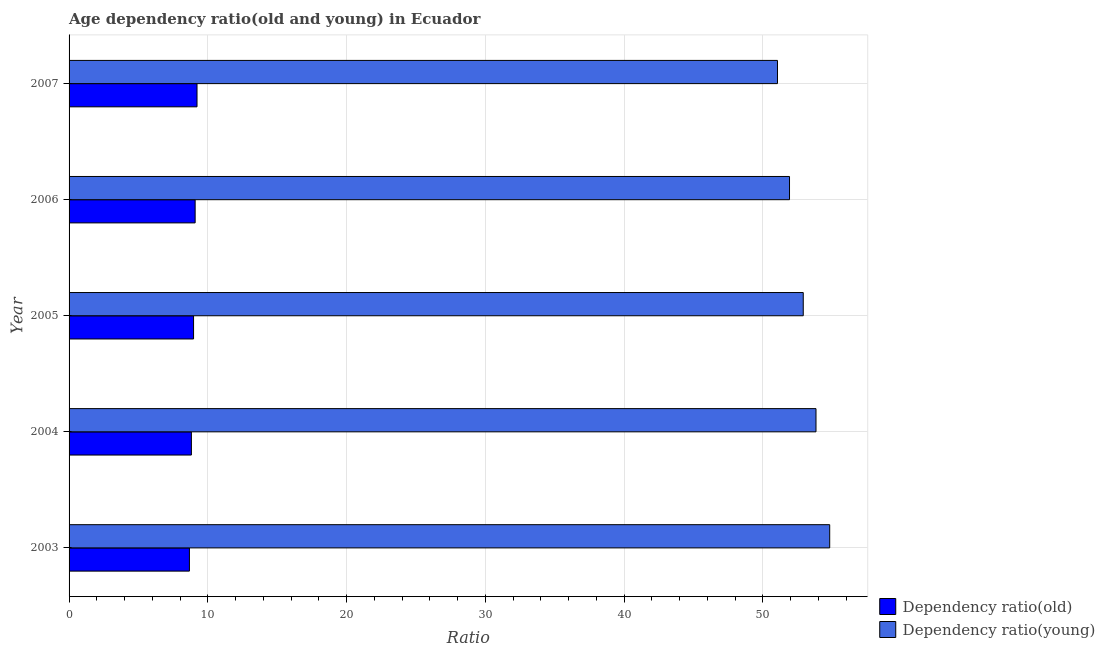How many different coloured bars are there?
Offer a very short reply. 2. How many groups of bars are there?
Keep it short and to the point. 5. In how many cases, is the number of bars for a given year not equal to the number of legend labels?
Ensure brevity in your answer.  0. What is the age dependency ratio(young) in 2005?
Your answer should be very brief. 52.92. Across all years, what is the maximum age dependency ratio(old)?
Your answer should be compact. 9.22. Across all years, what is the minimum age dependency ratio(old)?
Offer a very short reply. 8.67. In which year was the age dependency ratio(old) maximum?
Your answer should be compact. 2007. In which year was the age dependency ratio(young) minimum?
Keep it short and to the point. 2007. What is the total age dependency ratio(young) in the graph?
Ensure brevity in your answer.  264.57. What is the difference between the age dependency ratio(old) in 2003 and that in 2007?
Offer a very short reply. -0.55. What is the difference between the age dependency ratio(young) in 2004 and the age dependency ratio(old) in 2005?
Your response must be concise. 44.86. What is the average age dependency ratio(young) per year?
Give a very brief answer. 52.91. In the year 2006, what is the difference between the age dependency ratio(old) and age dependency ratio(young)?
Your answer should be very brief. -42.84. In how many years, is the age dependency ratio(young) greater than 24 ?
Ensure brevity in your answer.  5. What is the ratio of the age dependency ratio(old) in 2003 to that in 2005?
Ensure brevity in your answer.  0.97. Is the difference between the age dependency ratio(old) in 2004 and 2007 greater than the difference between the age dependency ratio(young) in 2004 and 2007?
Your answer should be very brief. No. What is the difference between the highest and the lowest age dependency ratio(young)?
Offer a terse response. 3.76. In how many years, is the age dependency ratio(young) greater than the average age dependency ratio(young) taken over all years?
Your answer should be very brief. 3. Is the sum of the age dependency ratio(old) in 2004 and 2007 greater than the maximum age dependency ratio(young) across all years?
Provide a succinct answer. No. What does the 2nd bar from the top in 2004 represents?
Give a very brief answer. Dependency ratio(old). What does the 1st bar from the bottom in 2003 represents?
Give a very brief answer. Dependency ratio(old). How many bars are there?
Offer a very short reply. 10. Are all the bars in the graph horizontal?
Give a very brief answer. Yes. What is the difference between two consecutive major ticks on the X-axis?
Your answer should be compact. 10. Does the graph contain any zero values?
Make the answer very short. No. How many legend labels are there?
Keep it short and to the point. 2. How are the legend labels stacked?
Make the answer very short. Vertical. What is the title of the graph?
Your answer should be very brief. Age dependency ratio(old and young) in Ecuador. Does "Young" appear as one of the legend labels in the graph?
Offer a terse response. No. What is the label or title of the X-axis?
Offer a terse response. Ratio. What is the label or title of the Y-axis?
Keep it short and to the point. Year. What is the Ratio in Dependency ratio(old) in 2003?
Your answer should be compact. 8.67. What is the Ratio of Dependency ratio(young) in 2003?
Offer a very short reply. 54.83. What is the Ratio of Dependency ratio(old) in 2004?
Provide a short and direct response. 8.82. What is the Ratio in Dependency ratio(young) in 2004?
Keep it short and to the point. 53.84. What is the Ratio of Dependency ratio(old) in 2005?
Ensure brevity in your answer.  8.97. What is the Ratio of Dependency ratio(young) in 2005?
Offer a very short reply. 52.92. What is the Ratio of Dependency ratio(old) in 2006?
Keep it short and to the point. 9.09. What is the Ratio of Dependency ratio(young) in 2006?
Make the answer very short. 51.93. What is the Ratio of Dependency ratio(old) in 2007?
Provide a short and direct response. 9.22. What is the Ratio in Dependency ratio(young) in 2007?
Provide a succinct answer. 51.06. Across all years, what is the maximum Ratio in Dependency ratio(old)?
Keep it short and to the point. 9.22. Across all years, what is the maximum Ratio of Dependency ratio(young)?
Your answer should be compact. 54.83. Across all years, what is the minimum Ratio of Dependency ratio(old)?
Your answer should be compact. 8.67. Across all years, what is the minimum Ratio in Dependency ratio(young)?
Offer a very short reply. 51.06. What is the total Ratio in Dependency ratio(old) in the graph?
Ensure brevity in your answer.  44.77. What is the total Ratio in Dependency ratio(young) in the graph?
Provide a succinct answer. 264.57. What is the difference between the Ratio of Dependency ratio(old) in 2003 and that in 2004?
Provide a succinct answer. -0.14. What is the difference between the Ratio of Dependency ratio(young) in 2003 and that in 2004?
Provide a short and direct response. 0.99. What is the difference between the Ratio of Dependency ratio(old) in 2003 and that in 2005?
Provide a succinct answer. -0.3. What is the difference between the Ratio of Dependency ratio(young) in 2003 and that in 2005?
Keep it short and to the point. 1.91. What is the difference between the Ratio of Dependency ratio(old) in 2003 and that in 2006?
Make the answer very short. -0.41. What is the difference between the Ratio of Dependency ratio(young) in 2003 and that in 2006?
Provide a succinct answer. 2.9. What is the difference between the Ratio in Dependency ratio(old) in 2003 and that in 2007?
Give a very brief answer. -0.55. What is the difference between the Ratio of Dependency ratio(young) in 2003 and that in 2007?
Provide a succinct answer. 3.76. What is the difference between the Ratio of Dependency ratio(old) in 2004 and that in 2005?
Give a very brief answer. -0.16. What is the difference between the Ratio of Dependency ratio(young) in 2004 and that in 2005?
Give a very brief answer. 0.92. What is the difference between the Ratio in Dependency ratio(old) in 2004 and that in 2006?
Provide a short and direct response. -0.27. What is the difference between the Ratio in Dependency ratio(young) in 2004 and that in 2006?
Make the answer very short. 1.91. What is the difference between the Ratio of Dependency ratio(old) in 2004 and that in 2007?
Provide a succinct answer. -0.41. What is the difference between the Ratio in Dependency ratio(young) in 2004 and that in 2007?
Give a very brief answer. 2.78. What is the difference between the Ratio of Dependency ratio(old) in 2005 and that in 2006?
Keep it short and to the point. -0.11. What is the difference between the Ratio of Dependency ratio(young) in 2005 and that in 2006?
Offer a terse response. 0.99. What is the difference between the Ratio in Dependency ratio(old) in 2005 and that in 2007?
Your answer should be compact. -0.25. What is the difference between the Ratio in Dependency ratio(young) in 2005 and that in 2007?
Your response must be concise. 1.86. What is the difference between the Ratio of Dependency ratio(old) in 2006 and that in 2007?
Offer a very short reply. -0.14. What is the difference between the Ratio in Dependency ratio(young) in 2006 and that in 2007?
Ensure brevity in your answer.  0.87. What is the difference between the Ratio of Dependency ratio(old) in 2003 and the Ratio of Dependency ratio(young) in 2004?
Offer a very short reply. -45.16. What is the difference between the Ratio of Dependency ratio(old) in 2003 and the Ratio of Dependency ratio(young) in 2005?
Your answer should be compact. -44.24. What is the difference between the Ratio of Dependency ratio(old) in 2003 and the Ratio of Dependency ratio(young) in 2006?
Offer a very short reply. -43.25. What is the difference between the Ratio of Dependency ratio(old) in 2003 and the Ratio of Dependency ratio(young) in 2007?
Offer a very short reply. -42.39. What is the difference between the Ratio in Dependency ratio(old) in 2004 and the Ratio in Dependency ratio(young) in 2005?
Offer a terse response. -44.1. What is the difference between the Ratio of Dependency ratio(old) in 2004 and the Ratio of Dependency ratio(young) in 2006?
Provide a succinct answer. -43.11. What is the difference between the Ratio in Dependency ratio(old) in 2004 and the Ratio in Dependency ratio(young) in 2007?
Ensure brevity in your answer.  -42.25. What is the difference between the Ratio of Dependency ratio(old) in 2005 and the Ratio of Dependency ratio(young) in 2006?
Your answer should be compact. -42.96. What is the difference between the Ratio of Dependency ratio(old) in 2005 and the Ratio of Dependency ratio(young) in 2007?
Provide a succinct answer. -42.09. What is the difference between the Ratio of Dependency ratio(old) in 2006 and the Ratio of Dependency ratio(young) in 2007?
Provide a succinct answer. -41.98. What is the average Ratio in Dependency ratio(old) per year?
Offer a terse response. 8.95. What is the average Ratio of Dependency ratio(young) per year?
Provide a succinct answer. 52.91. In the year 2003, what is the difference between the Ratio in Dependency ratio(old) and Ratio in Dependency ratio(young)?
Provide a short and direct response. -46.15. In the year 2004, what is the difference between the Ratio of Dependency ratio(old) and Ratio of Dependency ratio(young)?
Give a very brief answer. -45.02. In the year 2005, what is the difference between the Ratio in Dependency ratio(old) and Ratio in Dependency ratio(young)?
Your response must be concise. -43.95. In the year 2006, what is the difference between the Ratio of Dependency ratio(old) and Ratio of Dependency ratio(young)?
Keep it short and to the point. -42.84. In the year 2007, what is the difference between the Ratio of Dependency ratio(old) and Ratio of Dependency ratio(young)?
Offer a very short reply. -41.84. What is the ratio of the Ratio of Dependency ratio(old) in 2003 to that in 2004?
Provide a succinct answer. 0.98. What is the ratio of the Ratio in Dependency ratio(young) in 2003 to that in 2004?
Provide a succinct answer. 1.02. What is the ratio of the Ratio in Dependency ratio(old) in 2003 to that in 2005?
Offer a very short reply. 0.97. What is the ratio of the Ratio in Dependency ratio(young) in 2003 to that in 2005?
Provide a succinct answer. 1.04. What is the ratio of the Ratio in Dependency ratio(old) in 2003 to that in 2006?
Ensure brevity in your answer.  0.95. What is the ratio of the Ratio of Dependency ratio(young) in 2003 to that in 2006?
Your answer should be very brief. 1.06. What is the ratio of the Ratio of Dependency ratio(old) in 2003 to that in 2007?
Make the answer very short. 0.94. What is the ratio of the Ratio in Dependency ratio(young) in 2003 to that in 2007?
Make the answer very short. 1.07. What is the ratio of the Ratio in Dependency ratio(old) in 2004 to that in 2005?
Offer a terse response. 0.98. What is the ratio of the Ratio in Dependency ratio(young) in 2004 to that in 2005?
Offer a very short reply. 1.02. What is the ratio of the Ratio in Dependency ratio(old) in 2004 to that in 2006?
Make the answer very short. 0.97. What is the ratio of the Ratio in Dependency ratio(young) in 2004 to that in 2006?
Make the answer very short. 1.04. What is the ratio of the Ratio in Dependency ratio(old) in 2004 to that in 2007?
Provide a succinct answer. 0.96. What is the ratio of the Ratio of Dependency ratio(young) in 2004 to that in 2007?
Provide a succinct answer. 1.05. What is the ratio of the Ratio in Dependency ratio(old) in 2005 to that in 2006?
Make the answer very short. 0.99. What is the ratio of the Ratio of Dependency ratio(young) in 2005 to that in 2006?
Ensure brevity in your answer.  1.02. What is the ratio of the Ratio of Dependency ratio(young) in 2005 to that in 2007?
Provide a succinct answer. 1.04. What is the ratio of the Ratio of Dependency ratio(young) in 2006 to that in 2007?
Your answer should be compact. 1.02. What is the difference between the highest and the second highest Ratio in Dependency ratio(old)?
Provide a succinct answer. 0.14. What is the difference between the highest and the second highest Ratio of Dependency ratio(young)?
Offer a very short reply. 0.99. What is the difference between the highest and the lowest Ratio in Dependency ratio(old)?
Your answer should be compact. 0.55. What is the difference between the highest and the lowest Ratio in Dependency ratio(young)?
Offer a very short reply. 3.76. 